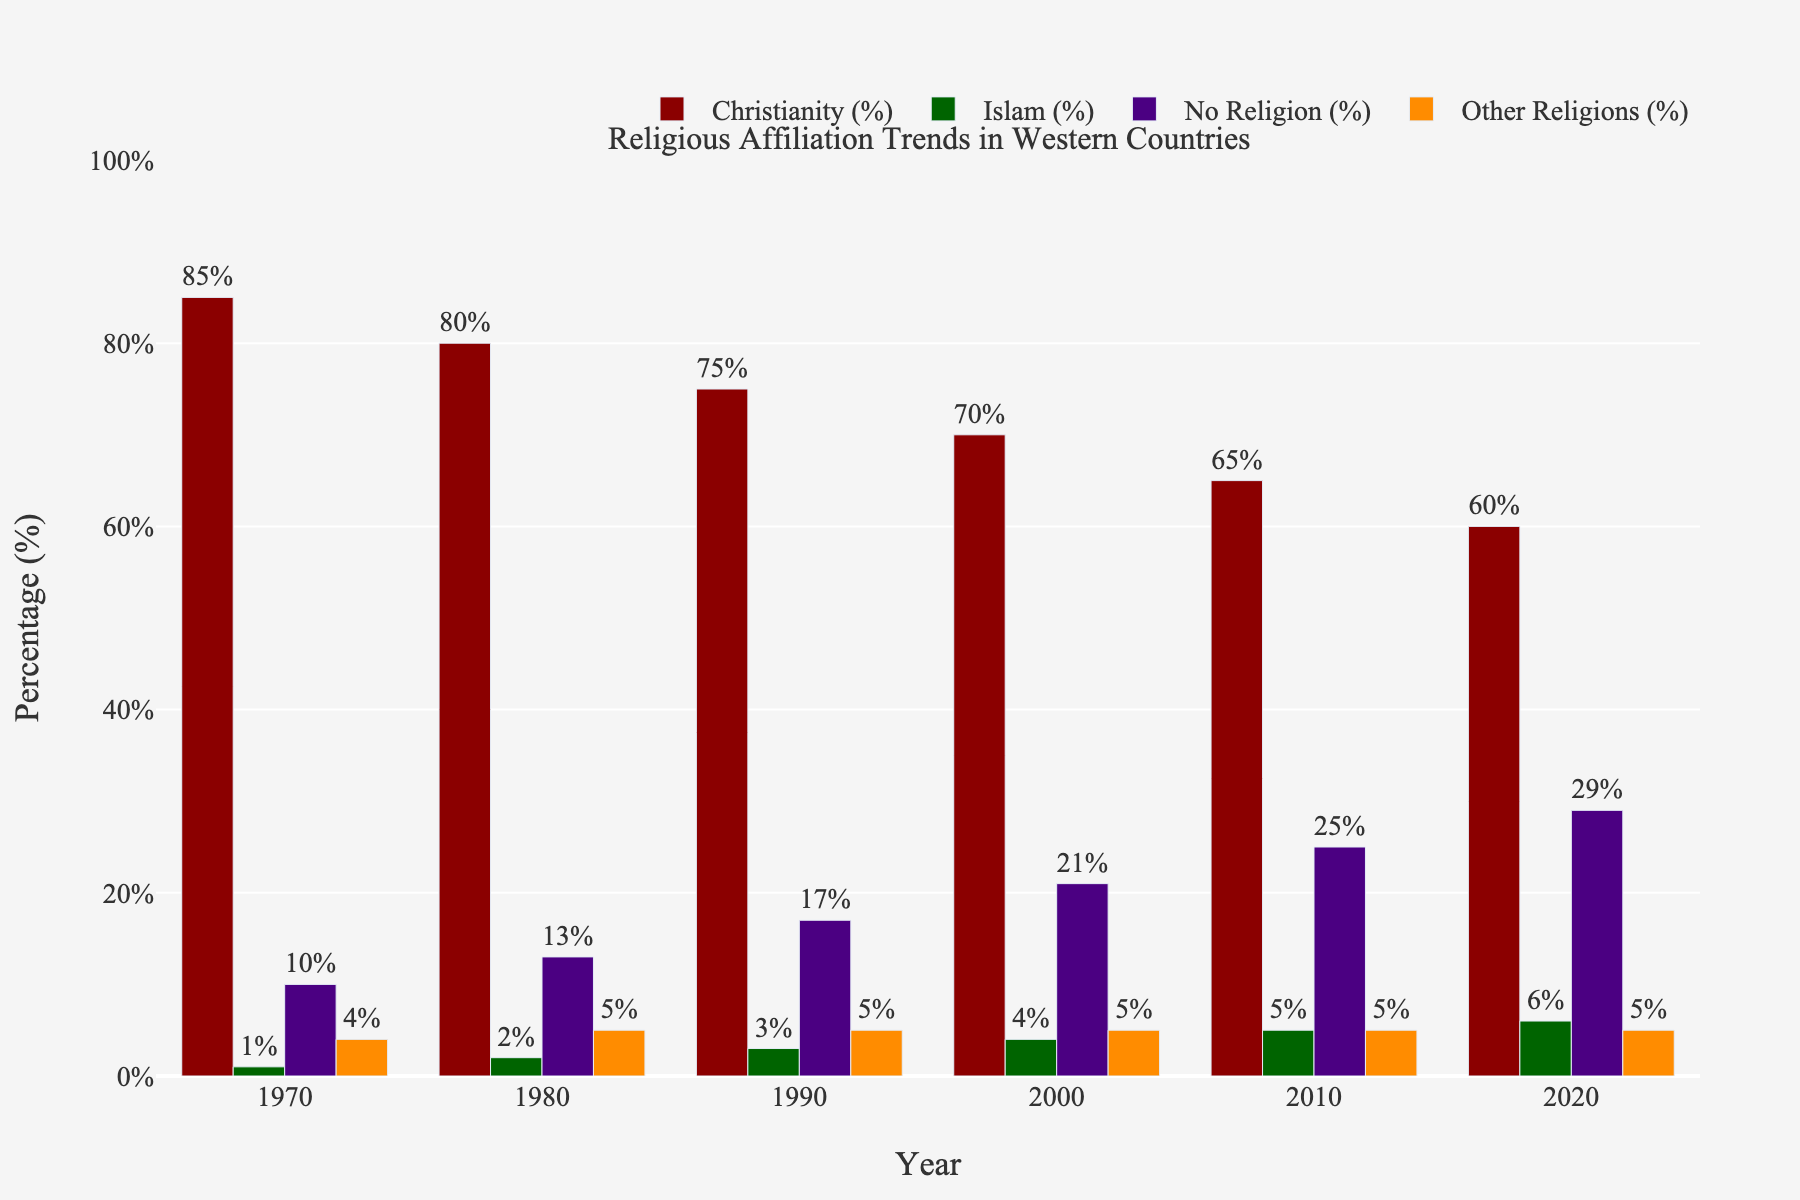What's the average percentage of Christianity for the years 1970 and 2020? The percentages of Christianity in 1970 and 2020 are 85% and 60%, respectively. The average is calculated by (85 + 60) / 2. This comes out to be 145 / 2 = 72.5.
Answer: 72.5% Between 2000 and 2020, which religious group shows the highest increase in percentage? Christianity drops from 70% to 60% (a decrease of 10%), Islam rises from 4% to 6% (an increase of 2%), No Religion increases from 21% to 29% (an increase of 8%), and Other Religions remains constant at 5%. Hence, the No Religion category shows the highest increase.
Answer: No Religion Which religious affiliation had the least percentage change between 1970 and 2020? The percentages in 1970 and 2020 for each group are Christianity: 85% to 60% (25% decrease), Islam: 1% to 6% (5% increase), No Religion: 10% to 29% (19% increase), Other Religions: 4% to 5% (1% increase). The Other Religions category had the least change.
Answer: Other Religions By how much has the percentage of people with No Religion increased from 1990 to 2010? In 1990, the percentage is 17%, and in 2010, it’s 25%. The increase is calculated by 25 - 17 = 8.
Answer: 8% In a given year, if you sum up the percentages of all religious affiliations, what should it yield? For a given year, the sum of all religious affiliation percentages should equal 100%, as it accounts for the entire population in percentages.
Answer: 100% What is the percentage difference between Christianity and No Religion in 2020? In 2020, the percentage for Christianity is 60%, and for No Religion, it’s 29%. The difference is calculated by 60 - 29 = 31.
Answer: 31% Which category consistently increased in percentage every decade? By examining each religious affiliation, Islam and No Religion percentages consistently increased every decade from 1970 to 2020. Therefore, both of these categories can be considered.
Answer: Islam and No Religion Comparing 1970 and 2020, which religious affiliation gained the highest percentage of followers? In 1970 the percentages are: Christianity 85%, Islam 1%, No Religion 10%, and Other Religions 4%. By 2020, Christianity is 60%, Islam 6%, No Religion 29%, and Other Religions 5%. The highest gain is seen in No Religion, increasing from 10% to 29%.
Answer: No Religion 